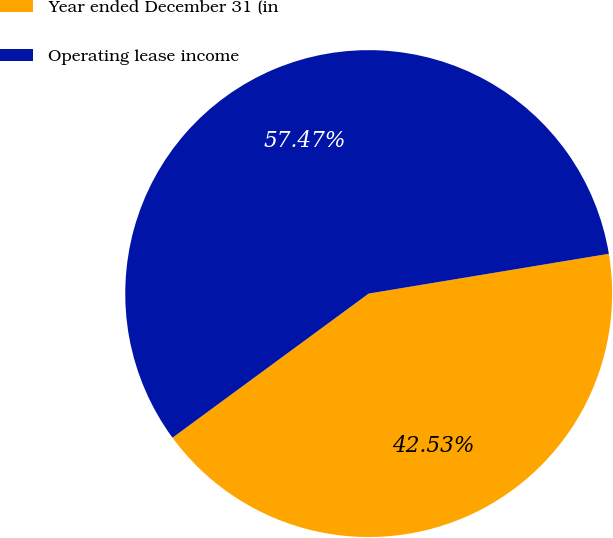<chart> <loc_0><loc_0><loc_500><loc_500><pie_chart><fcel>Year ended December 31 (in<fcel>Operating lease income<nl><fcel>42.53%<fcel>57.47%<nl></chart> 